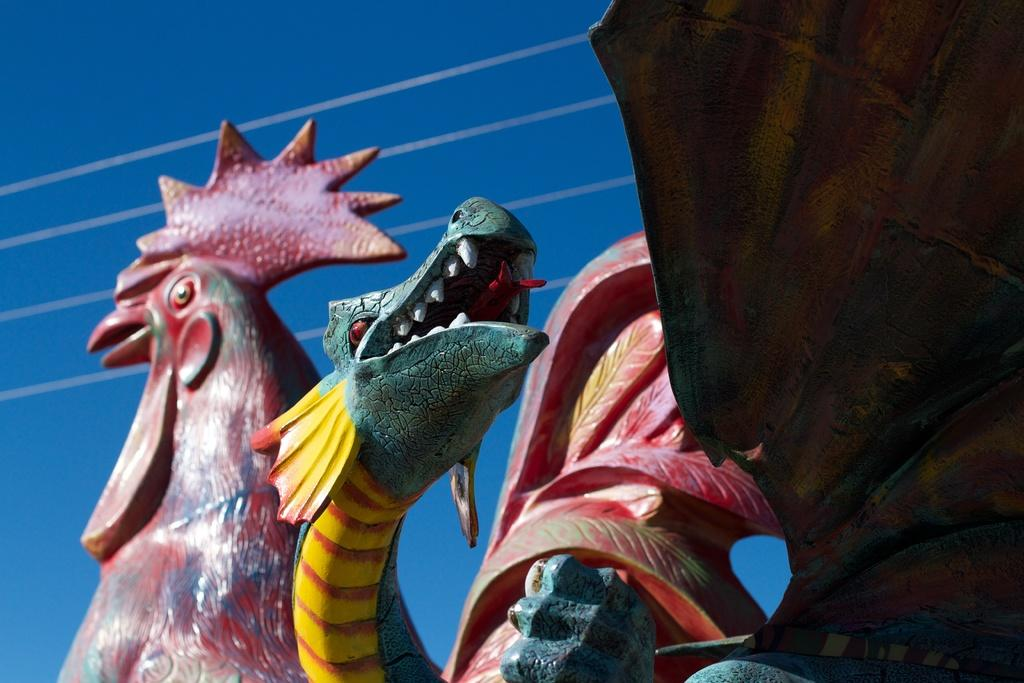What type of artwork can be seen in the image? There are sculptures in the image. What can be seen in the background of the image? There is sky visible in the background of the image. Are there any additional elements present in the image? Yes, there are wires in the image. What type of drum is being played in the image? There is no drum present in the image; it features sculptures and wires. What role does the lead play in the image? There is no mention of a lead or any leadership role in the image; it primarily focuses on sculptures and the sky. 